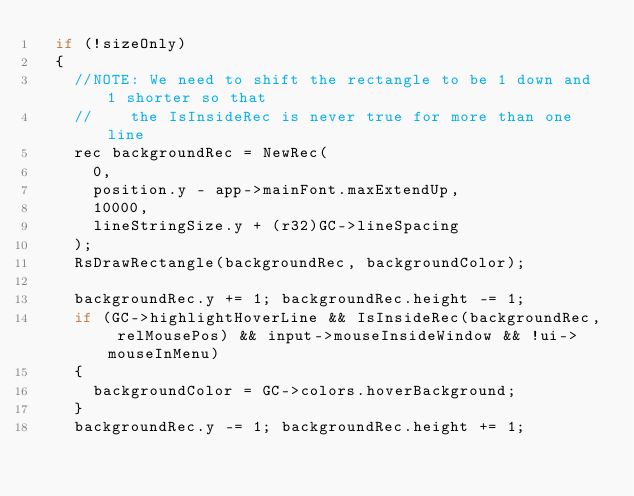<code> <loc_0><loc_0><loc_500><loc_500><_C++_>	if (!sizeOnly)
	{
		//NOTE: We need to shift the rectangle to be 1 down and 1 shorter so that
		//		the IsInsideRec is never true for more than one line
		rec backgroundRec = NewRec(
			0,
			position.y - app->mainFont.maxExtendUp,
			10000,
			lineStringSize.y + (r32)GC->lineSpacing
		);
		RsDrawRectangle(backgroundRec, backgroundColor);
		
		backgroundRec.y += 1; backgroundRec.height -= 1;
		if (GC->highlightHoverLine && IsInsideRec(backgroundRec, relMousePos) && input->mouseInsideWindow && !ui->mouseInMenu)
		{
			backgroundColor = GC->colors.hoverBackground;
		}
		backgroundRec.y -= 1; backgroundRec.height += 1;</code> 